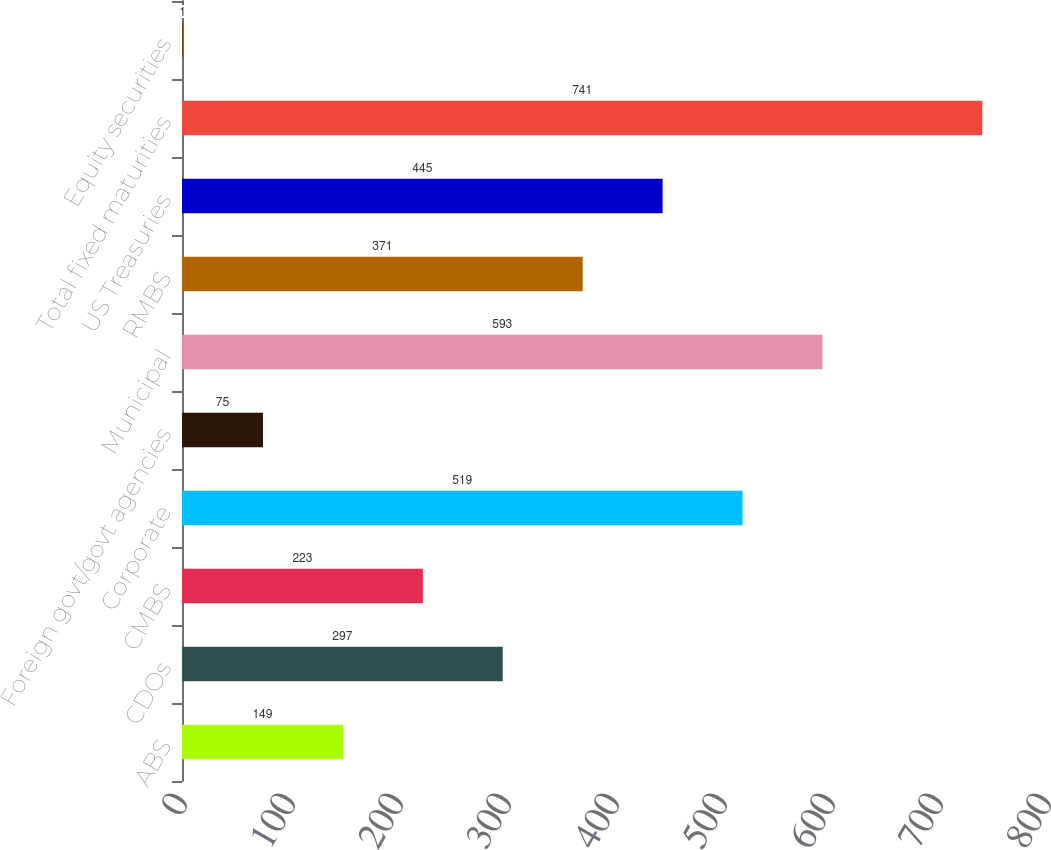Convert chart. <chart><loc_0><loc_0><loc_500><loc_500><bar_chart><fcel>ABS<fcel>CDOs<fcel>CMBS<fcel>Corporate<fcel>Foreign govt/govt agencies<fcel>Municipal<fcel>RMBS<fcel>US Treasuries<fcel>Total fixed maturities<fcel>Equity securities<nl><fcel>149<fcel>297<fcel>223<fcel>519<fcel>75<fcel>593<fcel>371<fcel>445<fcel>741<fcel>1<nl></chart> 